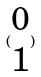Convert formula to latex. <formula><loc_0><loc_0><loc_500><loc_500>( \begin{matrix} 0 \\ 1 \end{matrix} )</formula> 